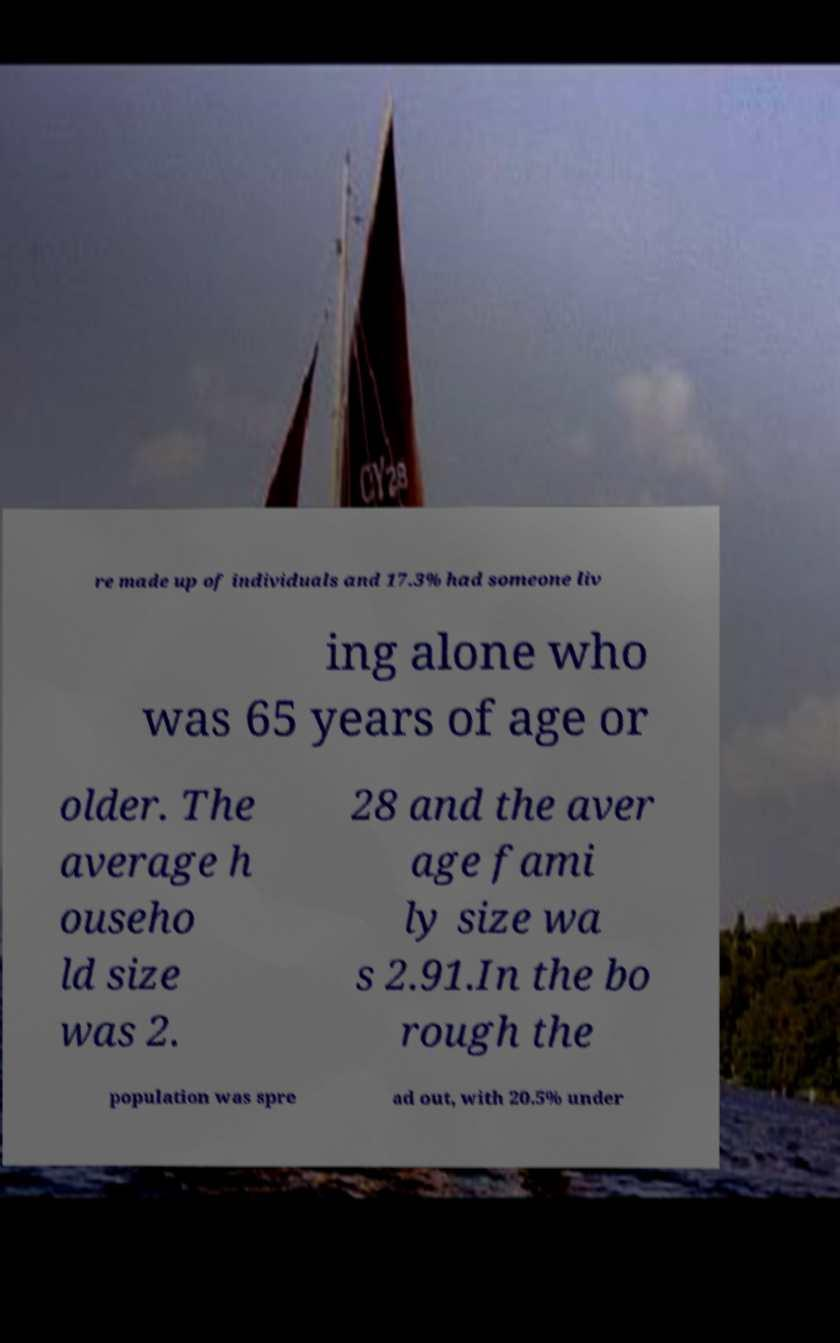There's text embedded in this image that I need extracted. Can you transcribe it verbatim? re made up of individuals and 17.3% had someone liv ing alone who was 65 years of age or older. The average h ouseho ld size was 2. 28 and the aver age fami ly size wa s 2.91.In the bo rough the population was spre ad out, with 20.5% under 